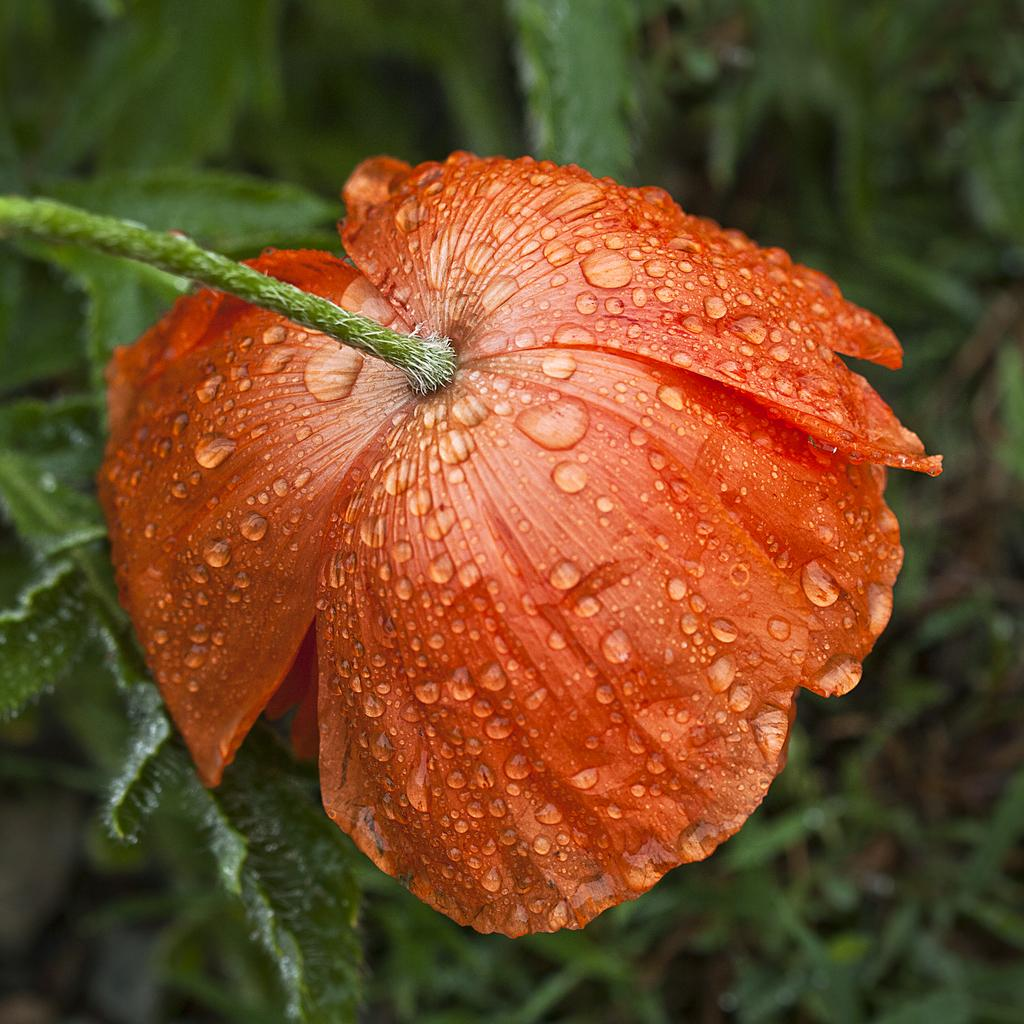What is the condition of the flower in the image? The flower in the image has water drops on it. What else can be seen in the image besides the flower? There are leaves visible in the image. What type of knot is tied around the church in the image? There is no church or knot present in the image; it features a flower with water drops and leaves. What advice does the mom give to her child in the image? There is no mom or child present in the image; it only shows a flower with water drops and leaves. 